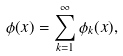Convert formula to latex. <formula><loc_0><loc_0><loc_500><loc_500>\phi ( x ) = \sum _ { k = 1 } ^ { \infty } \phi _ { k } ( x ) ,</formula> 